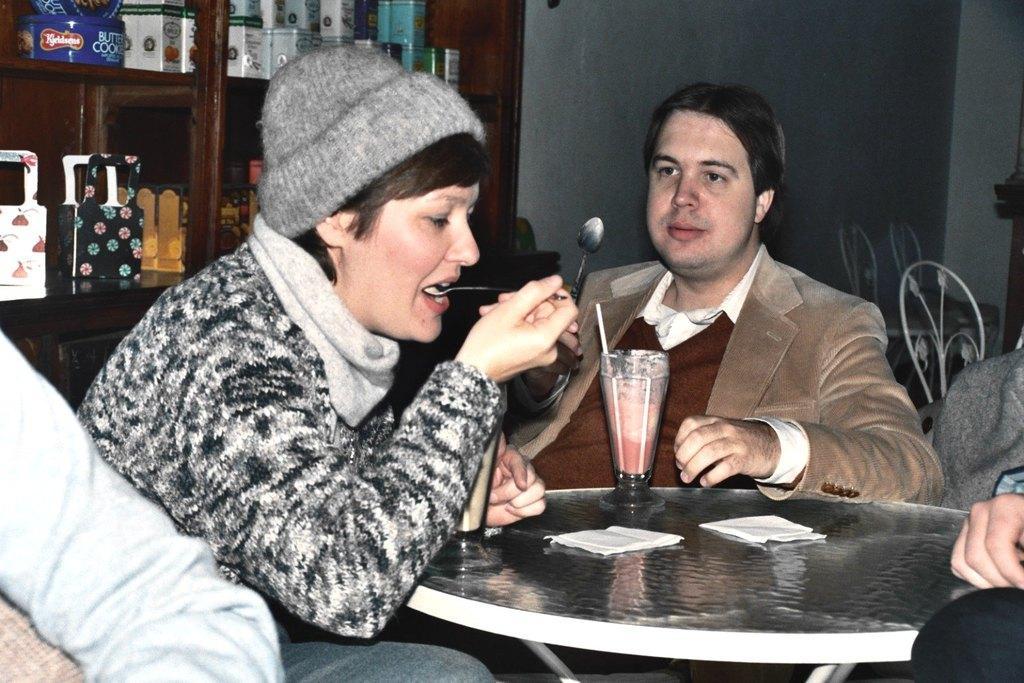Could you give a brief overview of what you see in this image? In this image I can see the persons sitting in front of the table. Among them one person is eating. At the back there is a cupboard. There are some objects in the cupboard. 